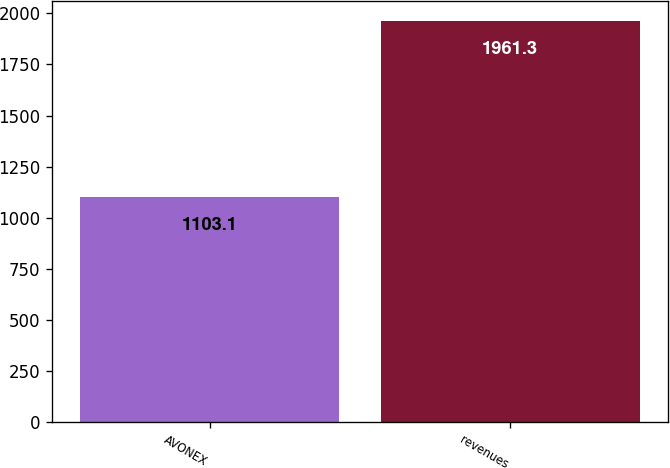Convert chart. <chart><loc_0><loc_0><loc_500><loc_500><bar_chart><fcel>AVONEX<fcel>revenues<nl><fcel>1103.1<fcel>1961.3<nl></chart> 